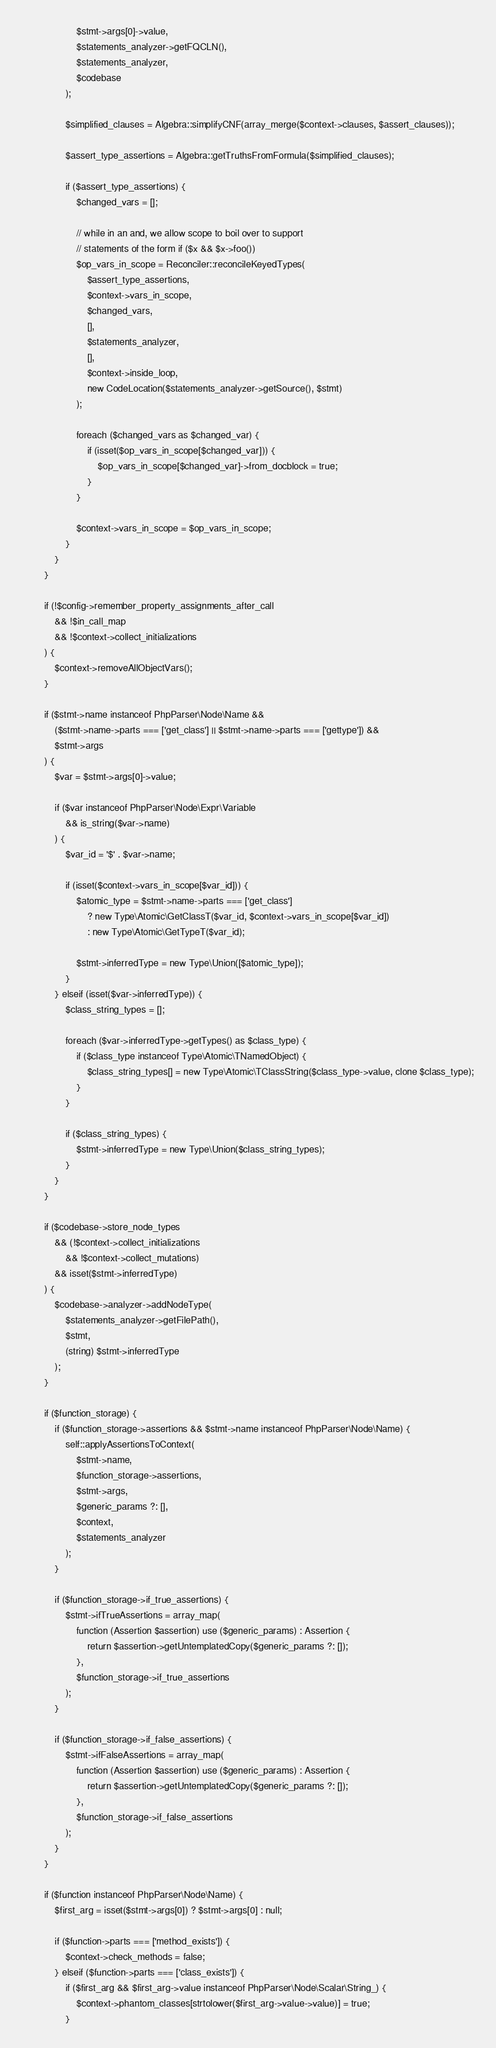Convert code to text. <code><loc_0><loc_0><loc_500><loc_500><_PHP_>                    $stmt->args[0]->value,
                    $statements_analyzer->getFQCLN(),
                    $statements_analyzer,
                    $codebase
                );

                $simplified_clauses = Algebra::simplifyCNF(array_merge($context->clauses, $assert_clauses));

                $assert_type_assertions = Algebra::getTruthsFromFormula($simplified_clauses);

                if ($assert_type_assertions) {
                    $changed_vars = [];

                    // while in an and, we allow scope to boil over to support
                    // statements of the form if ($x && $x->foo())
                    $op_vars_in_scope = Reconciler::reconcileKeyedTypes(
                        $assert_type_assertions,
                        $context->vars_in_scope,
                        $changed_vars,
                        [],
                        $statements_analyzer,
                        [],
                        $context->inside_loop,
                        new CodeLocation($statements_analyzer->getSource(), $stmt)
                    );

                    foreach ($changed_vars as $changed_var) {
                        if (isset($op_vars_in_scope[$changed_var])) {
                            $op_vars_in_scope[$changed_var]->from_docblock = true;
                        }
                    }

                    $context->vars_in_scope = $op_vars_in_scope;
                }
            }
        }

        if (!$config->remember_property_assignments_after_call
            && !$in_call_map
            && !$context->collect_initializations
        ) {
            $context->removeAllObjectVars();
        }

        if ($stmt->name instanceof PhpParser\Node\Name &&
            ($stmt->name->parts === ['get_class'] || $stmt->name->parts === ['gettype']) &&
            $stmt->args
        ) {
            $var = $stmt->args[0]->value;

            if ($var instanceof PhpParser\Node\Expr\Variable
                && is_string($var->name)
            ) {
                $var_id = '$' . $var->name;

                if (isset($context->vars_in_scope[$var_id])) {
                    $atomic_type = $stmt->name->parts === ['get_class']
                        ? new Type\Atomic\GetClassT($var_id, $context->vars_in_scope[$var_id])
                        : new Type\Atomic\GetTypeT($var_id);

                    $stmt->inferredType = new Type\Union([$atomic_type]);
                }
            } elseif (isset($var->inferredType)) {
                $class_string_types = [];

                foreach ($var->inferredType->getTypes() as $class_type) {
                    if ($class_type instanceof Type\Atomic\TNamedObject) {
                        $class_string_types[] = new Type\Atomic\TClassString($class_type->value, clone $class_type);
                    }
                }

                if ($class_string_types) {
                    $stmt->inferredType = new Type\Union($class_string_types);
                }
            }
        }

        if ($codebase->store_node_types
            && (!$context->collect_initializations
                && !$context->collect_mutations)
            && isset($stmt->inferredType)
        ) {
            $codebase->analyzer->addNodeType(
                $statements_analyzer->getFilePath(),
                $stmt,
                (string) $stmt->inferredType
            );
        }

        if ($function_storage) {
            if ($function_storage->assertions && $stmt->name instanceof PhpParser\Node\Name) {
                self::applyAssertionsToContext(
                    $stmt->name,
                    $function_storage->assertions,
                    $stmt->args,
                    $generic_params ?: [],
                    $context,
                    $statements_analyzer
                );
            }

            if ($function_storage->if_true_assertions) {
                $stmt->ifTrueAssertions = array_map(
                    function (Assertion $assertion) use ($generic_params) : Assertion {
                        return $assertion->getUntemplatedCopy($generic_params ?: []);
                    },
                    $function_storage->if_true_assertions
                );
            }

            if ($function_storage->if_false_assertions) {
                $stmt->ifFalseAssertions = array_map(
                    function (Assertion $assertion) use ($generic_params) : Assertion {
                        return $assertion->getUntemplatedCopy($generic_params ?: []);
                    },
                    $function_storage->if_false_assertions
                );
            }
        }

        if ($function instanceof PhpParser\Node\Name) {
            $first_arg = isset($stmt->args[0]) ? $stmt->args[0] : null;

            if ($function->parts === ['method_exists']) {
                $context->check_methods = false;
            } elseif ($function->parts === ['class_exists']) {
                if ($first_arg && $first_arg->value instanceof PhpParser\Node\Scalar\String_) {
                    $context->phantom_classes[strtolower($first_arg->value->value)] = true;
                }</code> 